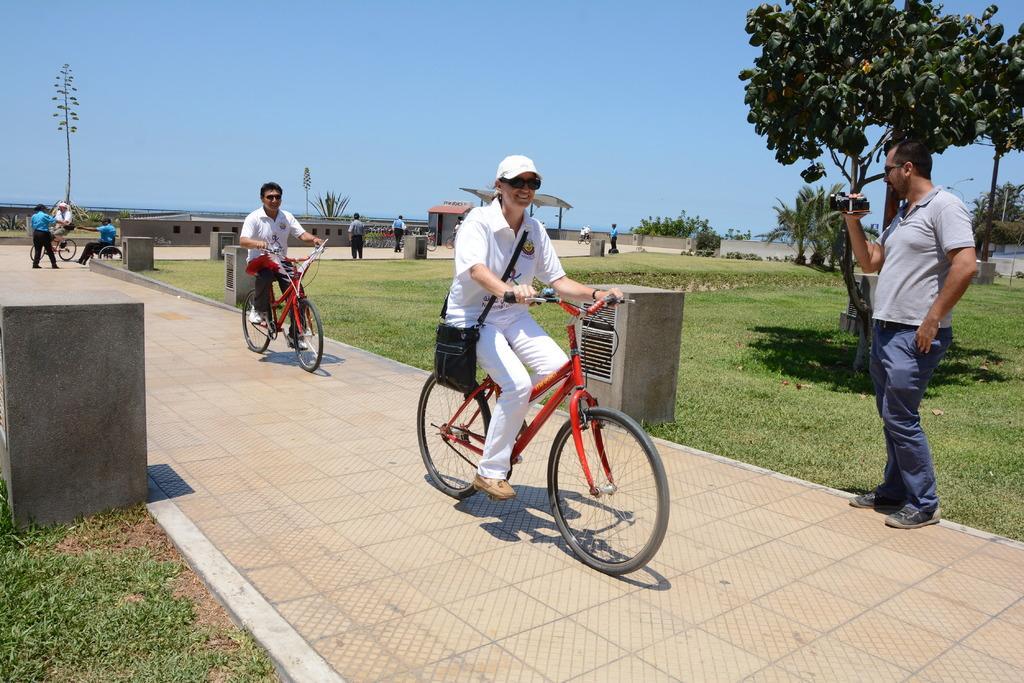How would you summarize this image in a sentence or two? In the middle, there are two person riding a bicycle. In the right middle, a person is standing and holding a camera in his hand. In the background, there is one person riding a bicycle and two person are standing in front of him. On both side of the image, there is a grass. In the background top sky is visible of blue in color. Below to that a tree is there. In the middle, houses are there. This image is taken during a sunny day. 